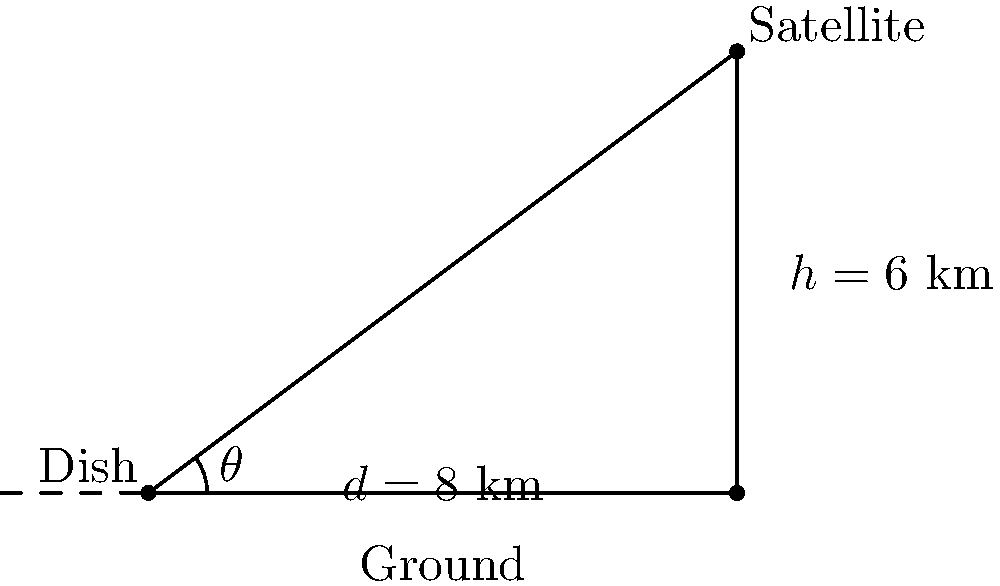A satellite dish needs to be positioned to receive the strongest signal from a satellite. The satellite is located 6 km above the ground and 8 km away horizontally from the dish. At what angle $\theta$ (in degrees) should the dish be tilted upwards from the horizontal to point directly at the satellite for optimal signal reception? To solve this problem, we'll use trigonometry, specifically the arctangent function. Let's break it down step-by-step:

1) We have a right triangle with the following measurements:
   - Adjacent side (horizontal distance): $d = 8$ km
   - Opposite side (vertical height): $h = 6$ km
   - The angle we're looking for: $\theta$

2) In a right triangle, tangent of an angle is the ratio of the opposite side to the adjacent side:

   $\tan(\theta) = \frac{\text{opposite}}{\text{adjacent}} = \frac{h}{d}$

3) Substituting our values:

   $\tan(\theta) = \frac{6}{8} = 0.75$

4) To find $\theta$, we need to use the inverse tangent (arctangent) function:

   $\theta = \arctan(0.75)$

5) Using a calculator or computer to evaluate this:

   $\theta \approx 36.87°$

6) Rounding to two decimal places:

   $\theta \approx 36.87°$

Therefore, the satellite dish should be tilted upwards at an angle of approximately 36.87° from the horizontal for optimal signal reception.
Answer: $36.87°$ 